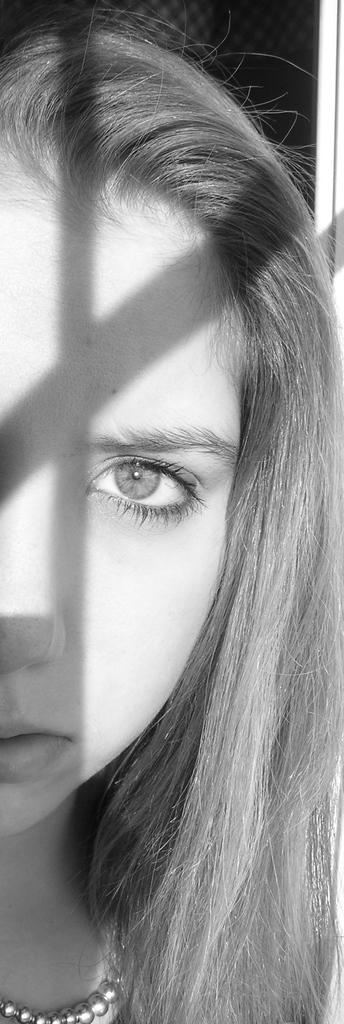What is the color scheme of the image? The image is black and white. What is the main subject of the image? There is a picture of a woman in the image. What accessory is the woman wearing in the image? The woman is wearing a silver chain around her neck. What color is the background of the image? The background of the image is black. What type of rod can be seen in the woman's hand in the image? There is no rod present in the image; the woman is not holding anything. How does the oatmeal look like in the image? There is no oatmeal present in the image. 